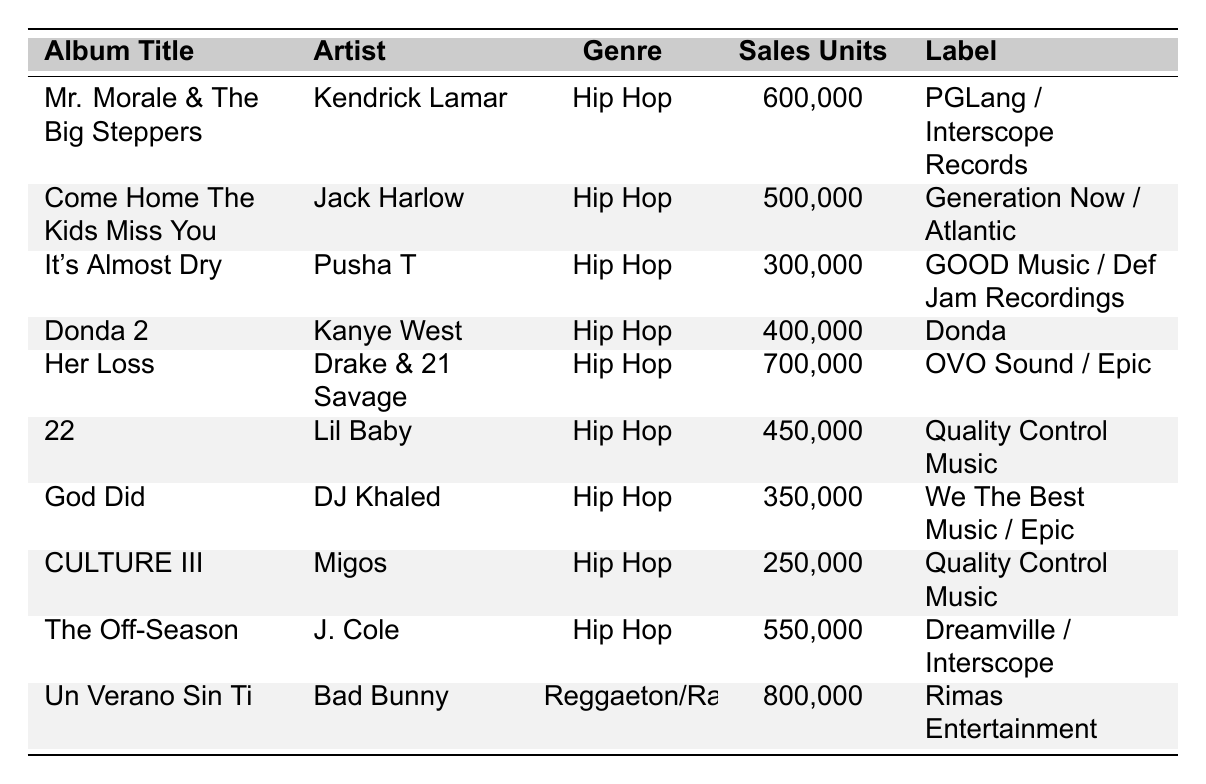What is the total sales of all Hip Hop albums? The Hip Hop albums listed in the table are: "Mr. Morale & The Big Steppers" (600,000), "Come Home The Kids Miss You" (500,000), "It's Almost Dry" (300,000), "Donda 2" (400,000), "Her Loss" (700,000), "22" (450,000), "God Did" (350,000), and "CULTURE III" (250,000). Adding these values gives: 600,000 + 500,000 + 300,000 + 400,000 + 700,000 + 450,000 + 350,000 + 250,000 = 3,600,000.
Answer: 3,600,000 Which album by Jack Harlow has the second highest sales? Jack Harlow's album is "Come Home The Kids Miss You" with total sales of 500,000. It is the only album listed by him in the table, so it must be the second highest by default.
Answer: 500,000 Did any album surpass 700,000 in sales? The highest-selling album is "Un Verano Sin Ti" by Bad Bunny with 800,000 units, surpassing 700,000.
Answer: Yes Which genre has the highest total sales? The total sales for Hip Hop albums are 3,600,000, while "Un Verano Sin Ti" from Reggaeton/Rap alone has 800,000. Therefore, Hip Hop has the highest total sales when considering its multiple entries compared to the single one for Reggaeton/Rap.
Answer: Hip Hop What is the average sales unit for the albums in the table? There are a total of 9 albums with recorded sales. The total sales calculated earlier is 4,400,000 (3,600,000 for Hip Hop + 800,000 for Reggaeton/Rap). To find the average: 4,400,000 / 9 = 488,888.89, which rounds to 488,889.
Answer: 488,889 How many albums were released before June 2022? The albums released before June 2022 are "Donda 2" (February), "22" (January), "CULTURE III" (January), "It's Almost Dry" (April), and "Come Home The Kids Miss You" (May), totaling 5 albums.
Answer: 5 What is the difference in sales between the highest and lowest selling Hip Hop albums? The highest selling Hip Hop album is "Her Loss" with 700,000 sales, and the lowest is "CULTURE III" with 250,000 sales. The difference is calculated as: 700,000 - 250,000 = 450,000.
Answer: 450,000 Which artist had the most recent album release according to the table? The most recent album listed is "Her Loss" released on November 4, 2022, by Drake & 21 Savage, which is the latest date among all entries.
Answer: Drake & 21 Savage 